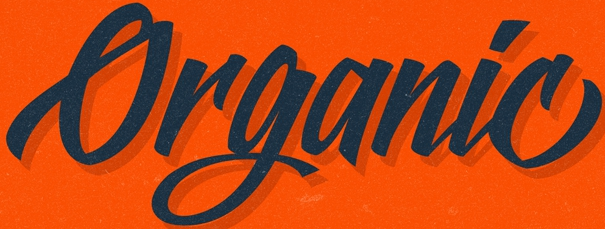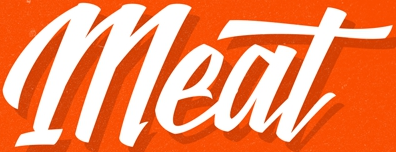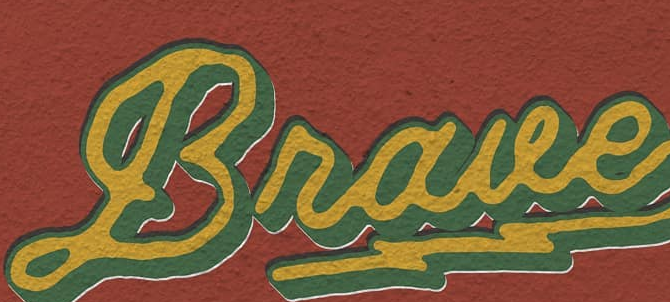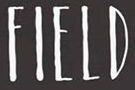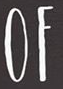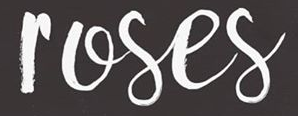What words can you see in these images in sequence, separated by a semicolon? Organic; Meat; Braue; FIELD; OF; roses 